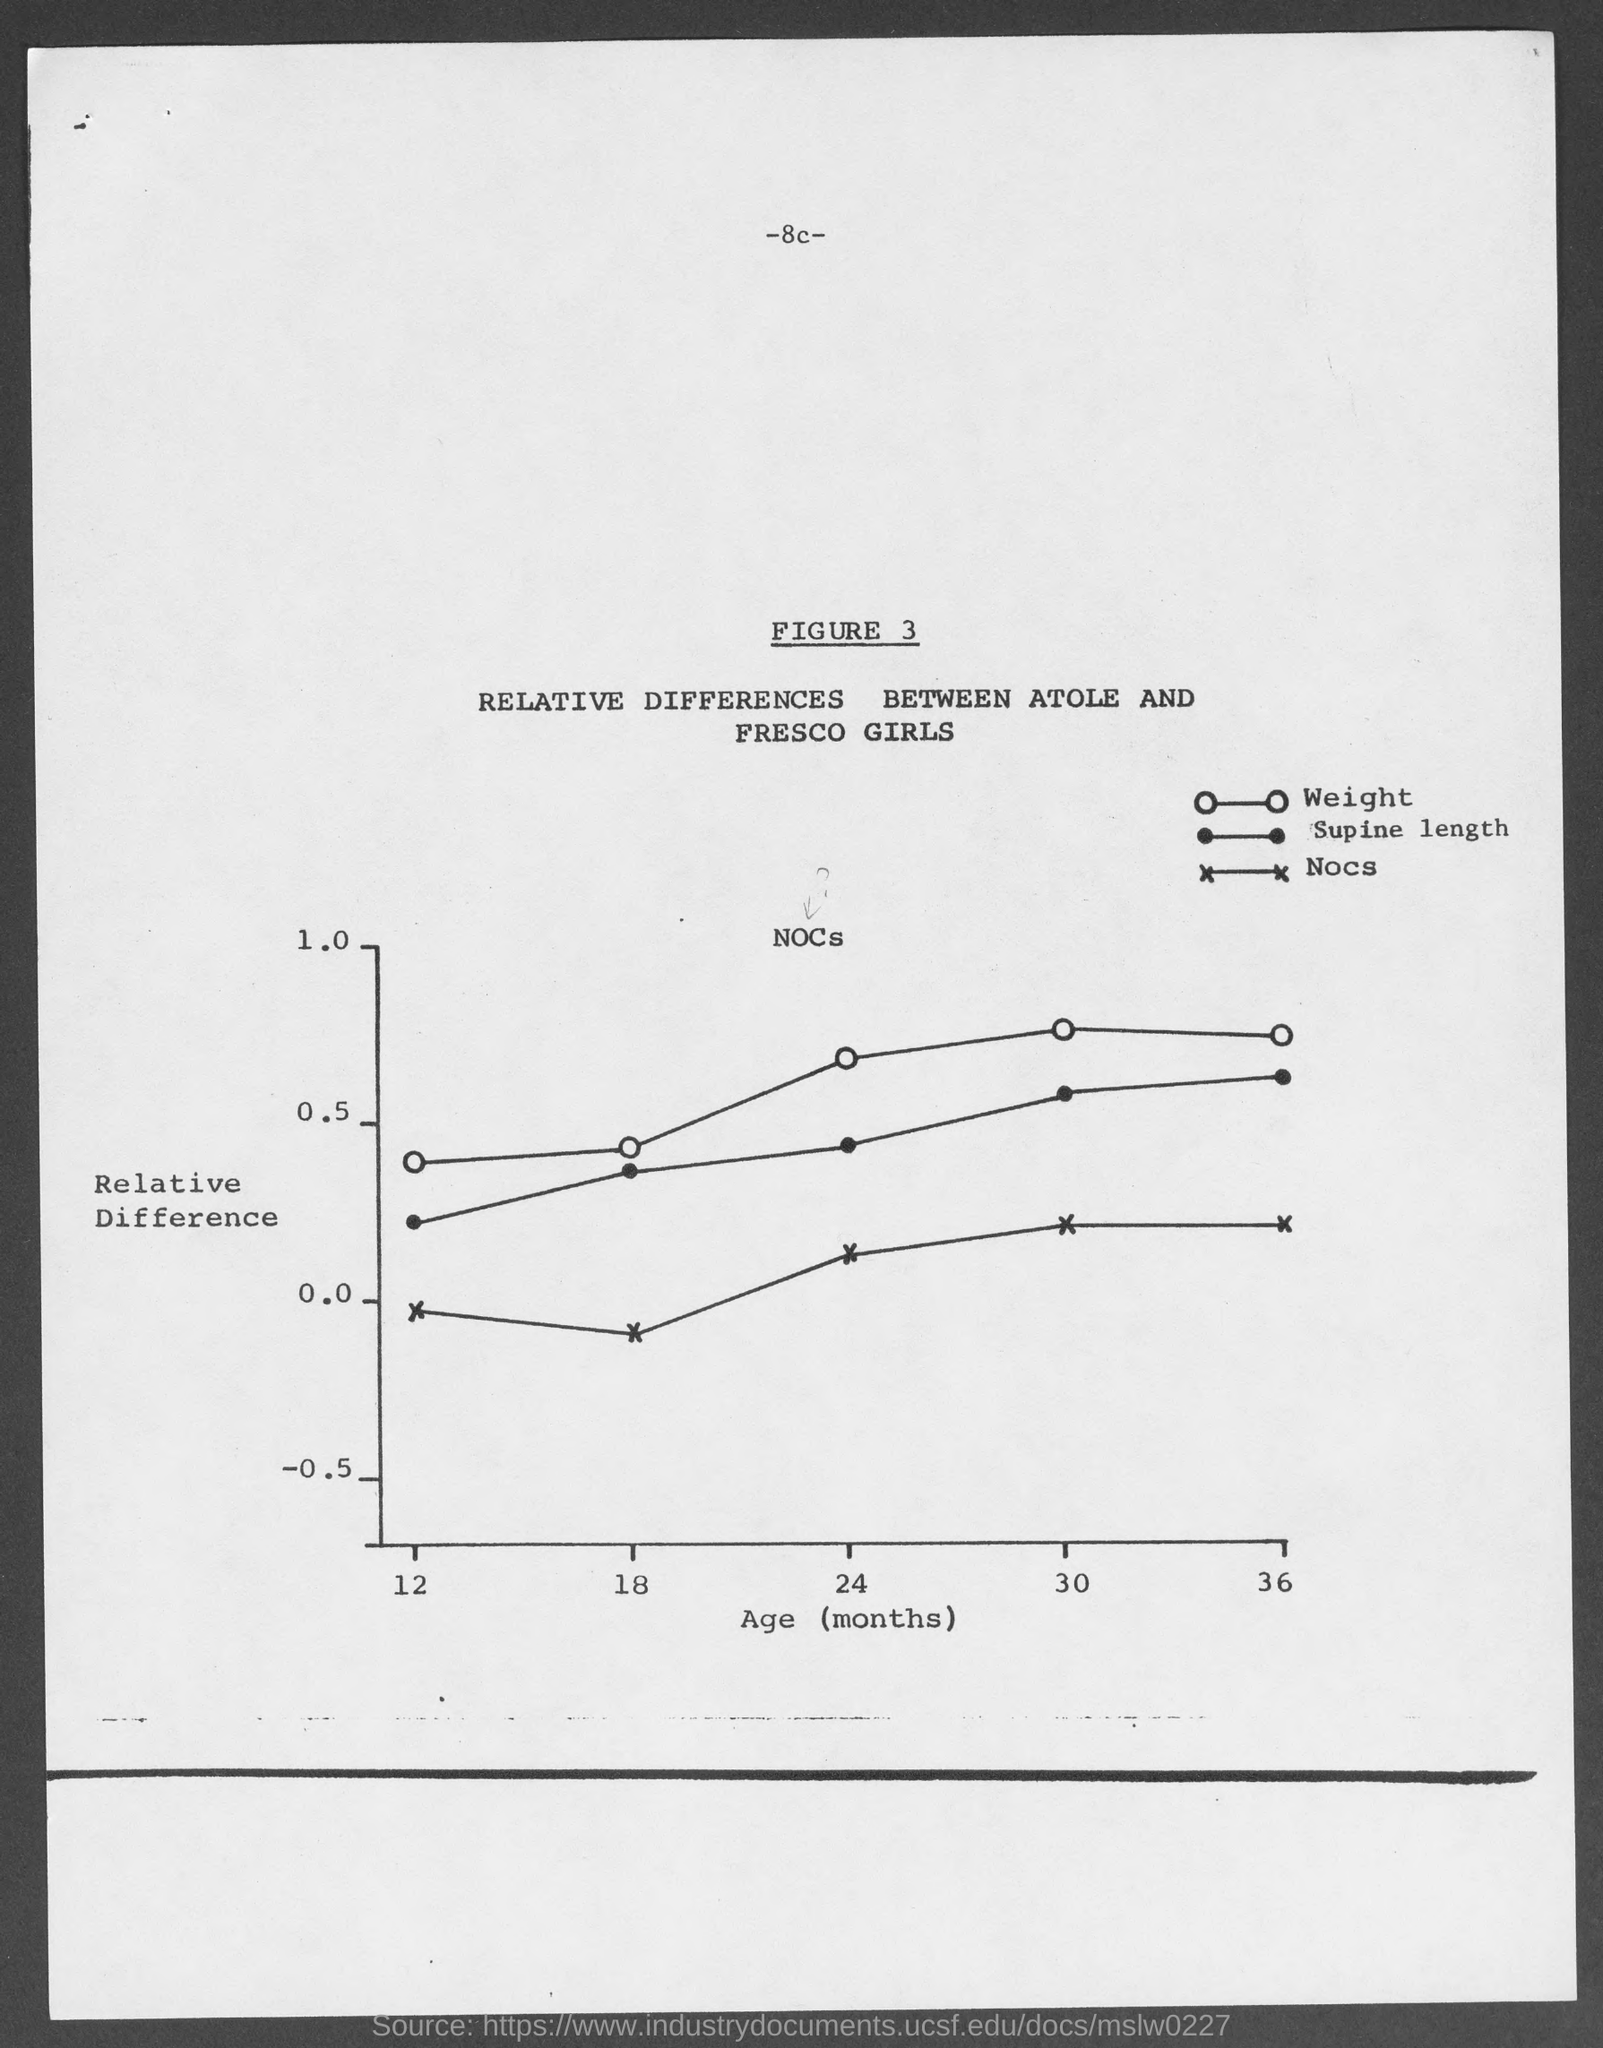What trend can be observed from the graph? The graph shows that as age increases from 12 to 36 months, there is a general upward trend in the relative differences of weight and supine length, with weight having a slightly more pronounced increase. Nocs, however, shows some fluctuation without a clear trend. This suggests that over time, there's a noticeable developmental progression in the weight and length of the girls in the study. 